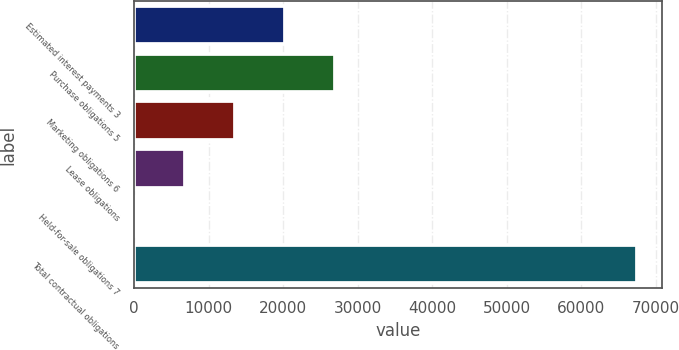Convert chart. <chart><loc_0><loc_0><loc_500><loc_500><bar_chart><fcel>Estimated interest payments 3<fcel>Purchase obligations 5<fcel>Marketing obligations 6<fcel>Lease obligations<fcel>Held-for-sale obligations 7<fcel>Total contractual obligations<nl><fcel>20268.3<fcel>27003.4<fcel>13533.2<fcel>6798.1<fcel>63<fcel>67414<nl></chart> 